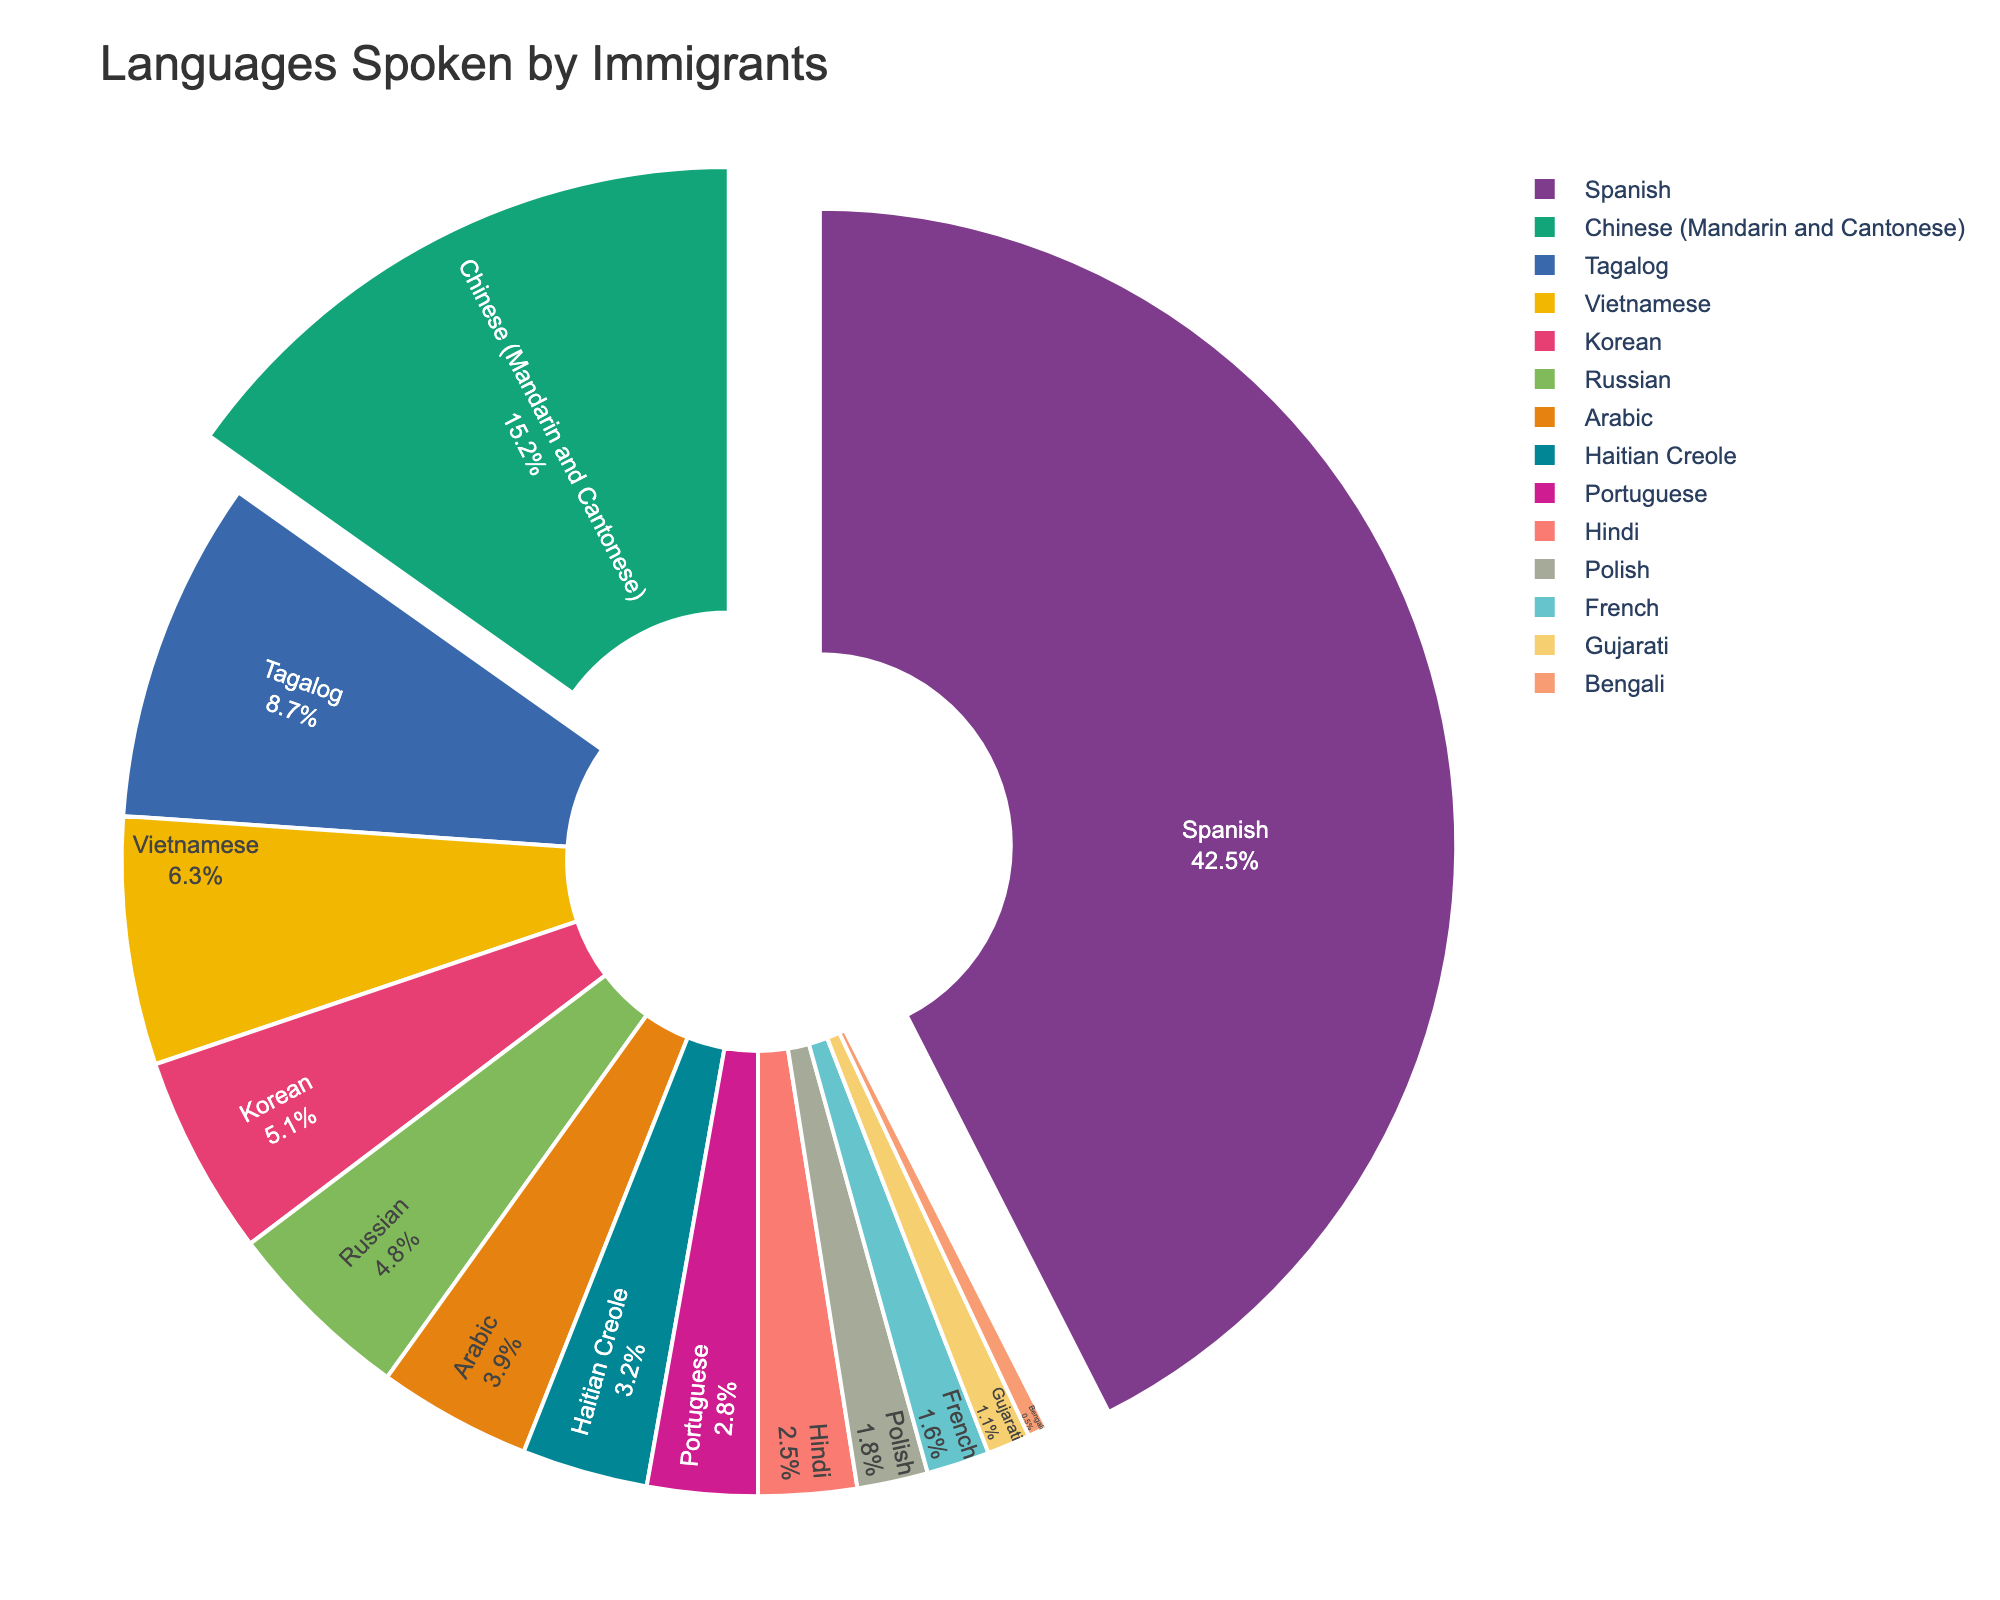Which language is spoken by the highest proportion of immigrants? By looking at the pie chart, we can see that Spanish occupies the largest section.
Answer: Spanish Which three languages have the smallest proportions in the chart? By examining the pie chart, the three smallest sections are Bengali, Gujarati, and French.
Answer: Bengali, Gujarati, French What's the combined percentage of immigrants speaking Vietnamese and Haitian Creole? Vietnamese has 6.3% and Haitian Creole has 3.2%. Adding these together gives us 6.3% + 3.2% = 9.5%.
Answer: 9.5% Which language has a higher proportion, Korean or Arabic? By comparing the size of the sections, Korean has 5.1% and Arabic has 3.9%. Therefore, Korean has a higher proportion.
Answer: Korean What's the difference in the proportion between Tagalog and Hindi? Tagalog has a proportion of 8.7%, and Hindi has a proportion of 2.5%. The difference is 8.7% - 2.5% = 6.2%.
Answer: 6.2% Is the proportion of immigrants speaking Portuguese greater or smaller than those speaking Russian? The pie chart shows Portuguese at 2.8% and Russian at 4.8%. Thus, Portuguese is smaller.
Answer: Smaller If you combine the proportions of Polish and French, does it exceed the proportion of Chinese speakers? Polish has 1.8% and French has 1.6%. Combining them gives 1.8% + 1.6% = 3.4%. Chinese speakers are at 15.2%, so 3.4% does not exceed 15.2%.
Answer: No What is the proportion of immigrants speaking languages other than Spanish, Chinese, and Tagalog? The total proportion for the three languages is 42.5% + 15.2% + 8.7% = 66.4%. Subtracting this from 100% gives 100% - 66.4% = 33.6%.
Answer: 33.6% Which language occupies the smallest section in the pie chart? The smallest section in the pie chart is Bengali with 0.5%.
Answer: Bengali How many languages have a proportion greater than 5%? By looking at the pie chart, the languages with proportions greater than 5% are Spanish (42.5%), Chinese (15.2%), Tagalog (8.7%), Vietnamese (6.3%), and Korean (5.1%). This totals to five languages.
Answer: Five 